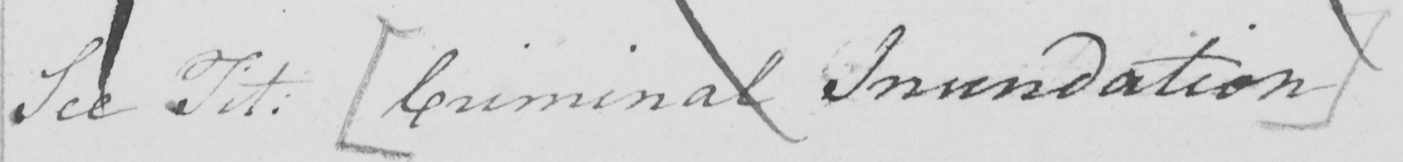Please provide the text content of this handwritten line. See Tit :   [ Criminal Inundation ] 